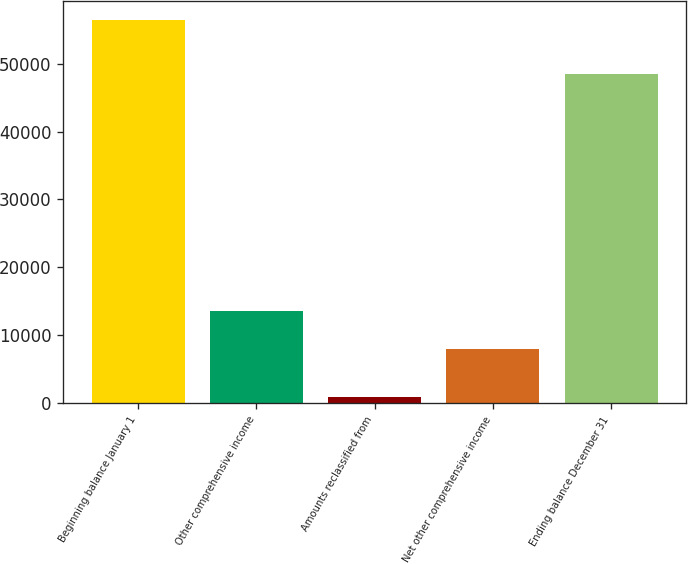Convert chart. <chart><loc_0><loc_0><loc_500><loc_500><bar_chart><fcel>Beginning balance January 1<fcel>Other comprehensive income<fcel>Amounts reclassified from<fcel>Net other comprehensive income<fcel>Ending balance December 31<nl><fcel>56412<fcel>13515.6<fcel>956<fcel>7970<fcel>48442<nl></chart> 